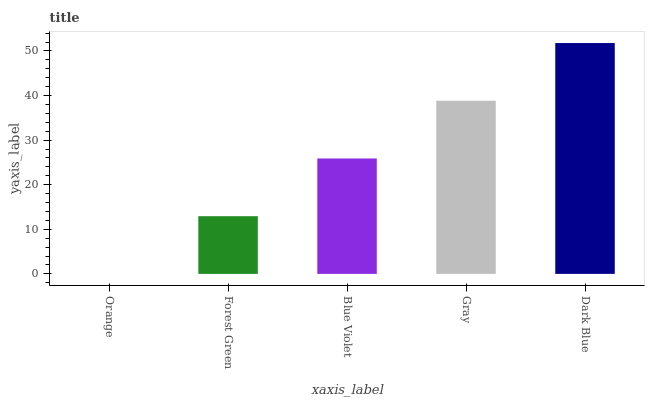Is Forest Green the minimum?
Answer yes or no. No. Is Forest Green the maximum?
Answer yes or no. No. Is Forest Green greater than Orange?
Answer yes or no. Yes. Is Orange less than Forest Green?
Answer yes or no. Yes. Is Orange greater than Forest Green?
Answer yes or no. No. Is Forest Green less than Orange?
Answer yes or no. No. Is Blue Violet the high median?
Answer yes or no. Yes. Is Blue Violet the low median?
Answer yes or no. Yes. Is Orange the high median?
Answer yes or no. No. Is Dark Blue the low median?
Answer yes or no. No. 